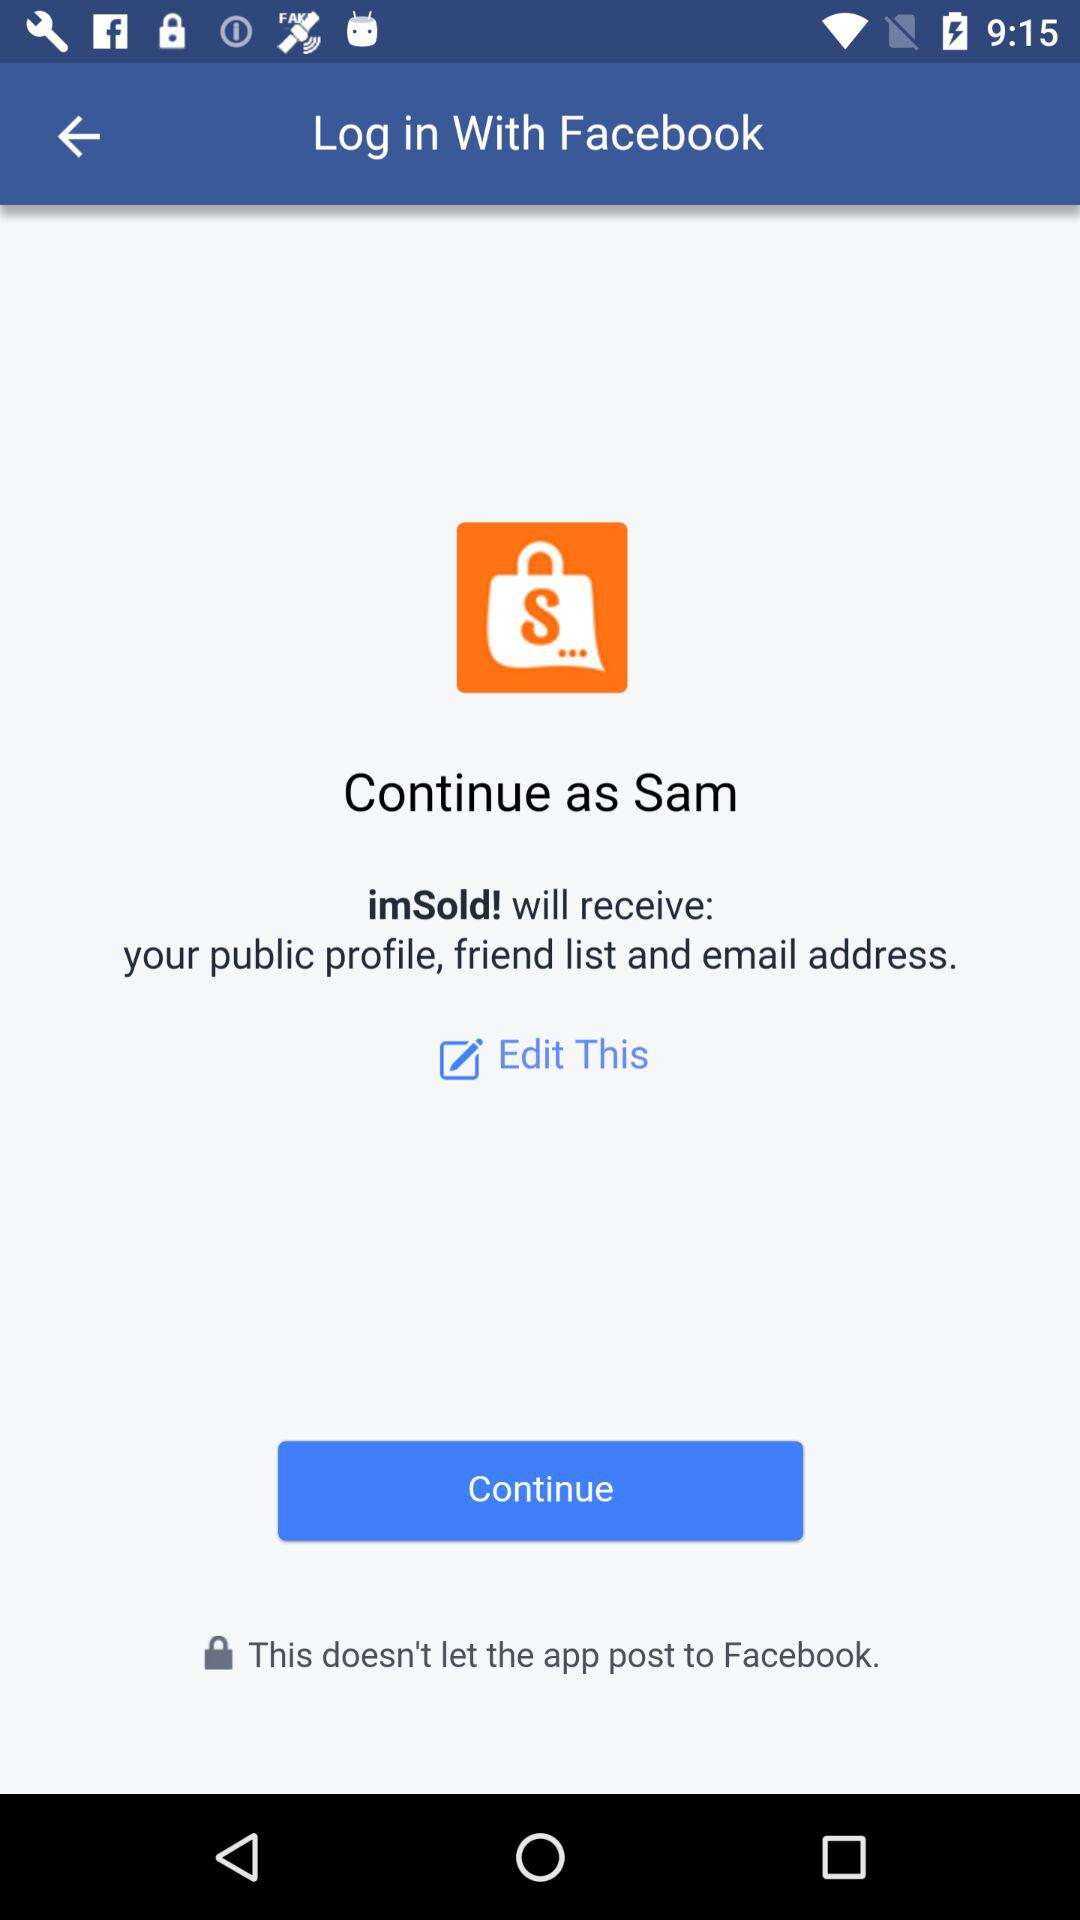What application will receive my public profile, email address, and friend list? The application is "imSold!". 